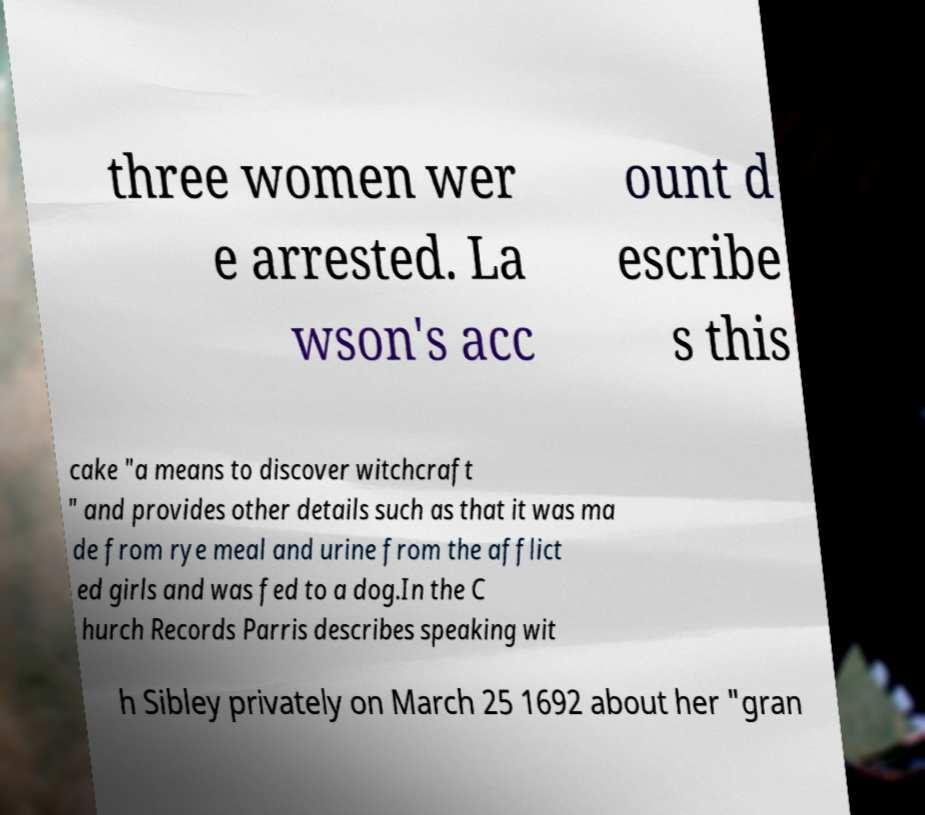For documentation purposes, I need the text within this image transcribed. Could you provide that? three women wer e arrested. La wson's acc ount d escribe s this cake "a means to discover witchcraft " and provides other details such as that it was ma de from rye meal and urine from the afflict ed girls and was fed to a dog.In the C hurch Records Parris describes speaking wit h Sibley privately on March 25 1692 about her "gran 